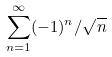Convert formula to latex. <formula><loc_0><loc_0><loc_500><loc_500>\sum _ { n = 1 } ^ { \infty } ( - 1 ) ^ { n } / \sqrt { n }</formula> 